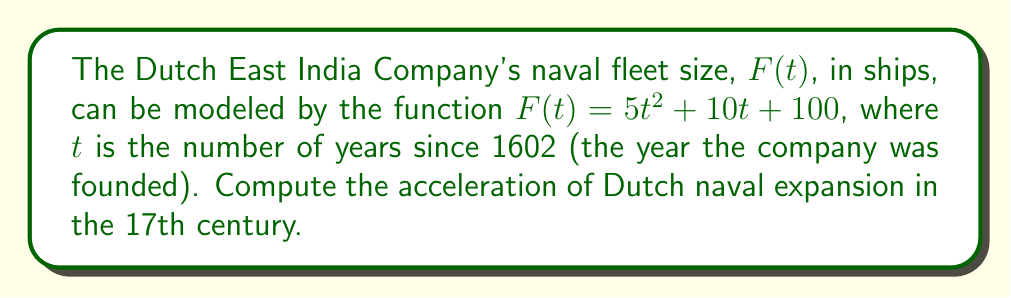What is the answer to this math problem? To find the acceleration of Dutch naval expansion, we need to calculate the second derivative of the fleet size function $F(t)$.

Step 1: Find the first derivative, $F'(t)$, which represents the rate of change (velocity) of fleet size.
$$F'(t) = \frac{d}{dt}(5t^2 + 10t + 100) = 10t + 10$$

Step 2: Find the second derivative, $F''(t)$, which represents the rate of change of the velocity (acceleration) of fleet size.
$$F''(t) = \frac{d}{dt}(10t + 10) = 10$$

The second derivative is a constant, which means the acceleration of Dutch naval expansion was constant throughout the 17th century.

Step 3: Interpret the result.
The acceleration of 10 ships per year squared means that each year, the rate of fleet expansion increased by 10 ships per year.
Answer: 10 ships/year² 